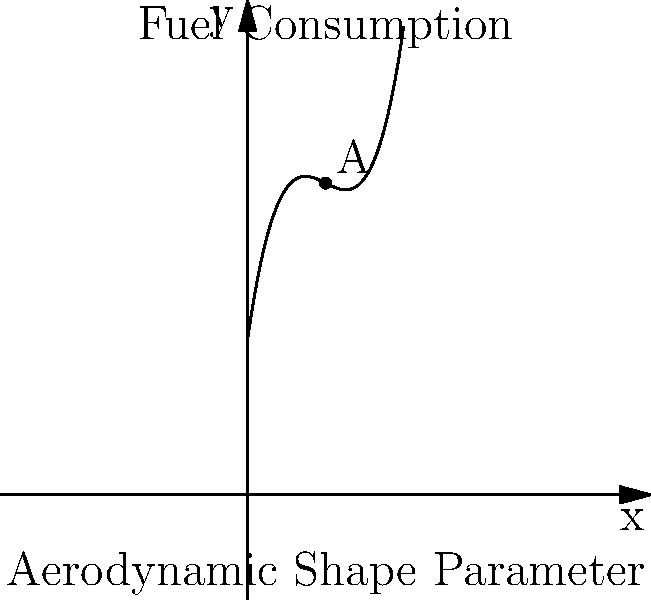The curve shown represents the relationship between a racing car's aerodynamic shape parameter (x-axis) and its fuel consumption (y-axis). If the function for fuel consumption is given by $f(x) = 0.1x^3 - 1.5x^2 + 7x + 10$, where x is the aerodynamic shape parameter, find the optimal value of x that minimizes fuel consumption. What is the corresponding minimum fuel consumption? To find the optimal value of x that minimizes fuel consumption, we need to follow these steps:

1) Find the derivative of the function:
   $f'(x) = 0.3x^2 - 3x + 7$

2) Set the derivative equal to zero to find critical points:
   $0.3x^2 - 3x + 7 = 0$

3) Solve the quadratic equation:
   $0.3(x^2 - 10x + \frac{70}{3}) = 0$
   $x^2 - 10x + \frac{70}{3} = 0$
   
   Using the quadratic formula: $x = \frac{-b \pm \sqrt{b^2 - 4ac}}{2a}$
   
   $x = \frac{10 \pm \sqrt{100 - 4(\frac{70}{3})}}{2} = \frac{10 \pm \sqrt{40}}{2}$

4) This gives us two critical points:
   $x_1 = 5 + \sqrt{10} \approx 8.16$
   $x_2 = 5 - \sqrt{10} \approx 1.84$

5) To determine which point gives the minimum, we can use the second derivative test:
   $f''(x) = 0.6x - 3$
   
   At $x_2 = 5 - \sqrt{10}$:
   $f''(5 - \sqrt{10}) = 0.6(5 - \sqrt{10}) - 3 = 3 - 0.6\sqrt{10} - 3 = -0.6\sqrt{10} < 0$

   This confirms that $x_2 = 5 - \sqrt{10}$ gives the minimum.

6) Calculate the minimum fuel consumption:
   $f(5 - \sqrt{10}) = 0.1(5 - \sqrt{10})^3 - 1.5(5 - \sqrt{10})^2 + 7(5 - \sqrt{10}) + 10$
   $\approx 20.77$

Therefore, the optimal aerodynamic shape parameter is approximately 1.84, and the corresponding minimum fuel consumption is approximately 20.77 units.
Answer: Optimal x ≈ 1.84, Minimum fuel consumption ≈ 20.77 